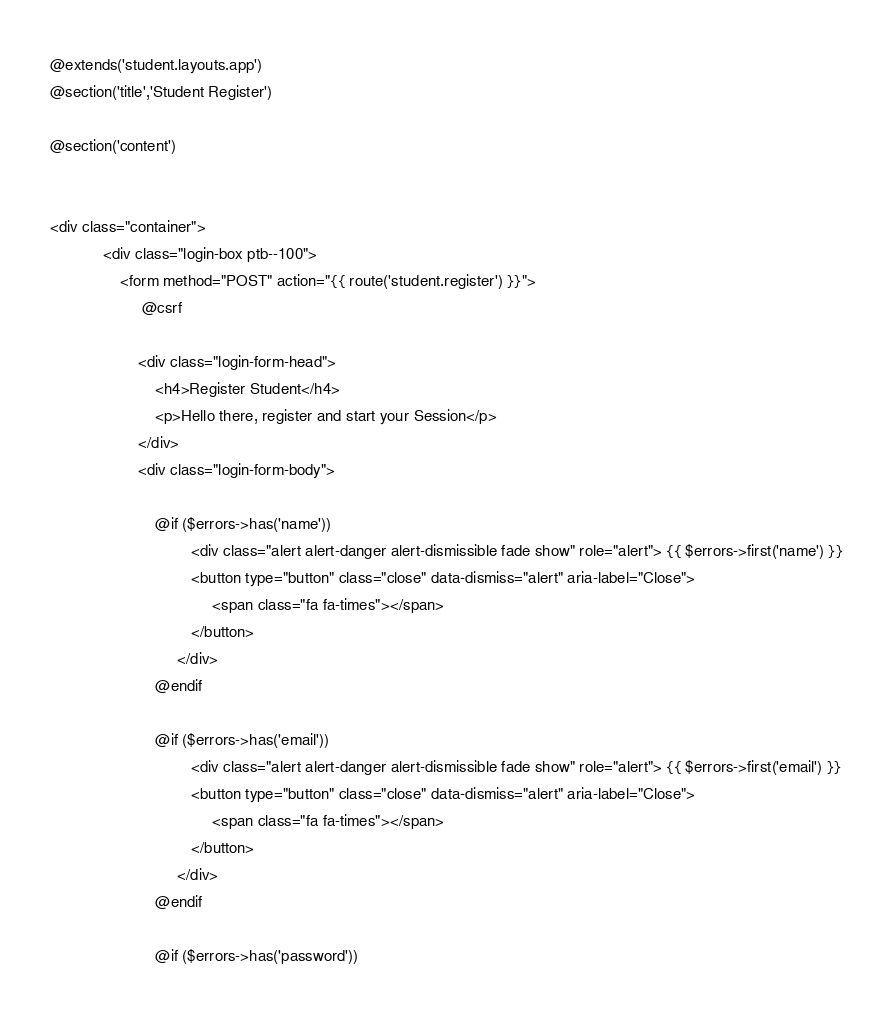<code> <loc_0><loc_0><loc_500><loc_500><_PHP_>@extends('student.layouts.app')
@section('title','Student Register')

@section('content')


<div class="container">
            <div class="login-box ptb--100">
                <form method="POST" action="{{ route('student.register') }}">
                     @csrf

                    <div class="login-form-head">
                        <h4>Register Student</h4>
                        <p>Hello there, register and start your Session</p>
                    </div>
                    <div class="login-form-body">

                        @if ($errors->has('name'))
                                <div class="alert alert-danger alert-dismissible fade show" role="alert"> {{ $errors->first('name') }}
                                <button type="button" class="close" data-dismiss="alert" aria-label="Close">
                                     <span class="fa fa-times"></span>
                                </button>
                             </div> 
                        @endif

                        @if ($errors->has('email'))
                                <div class="alert alert-danger alert-dismissible fade show" role="alert"> {{ $errors->first('email') }}
                                <button type="button" class="close" data-dismiss="alert" aria-label="Close">
                                     <span class="fa fa-times"></span>
                                </button>
                             </div> 
                        @endif

                        @if ($errors->has('password'))</code> 